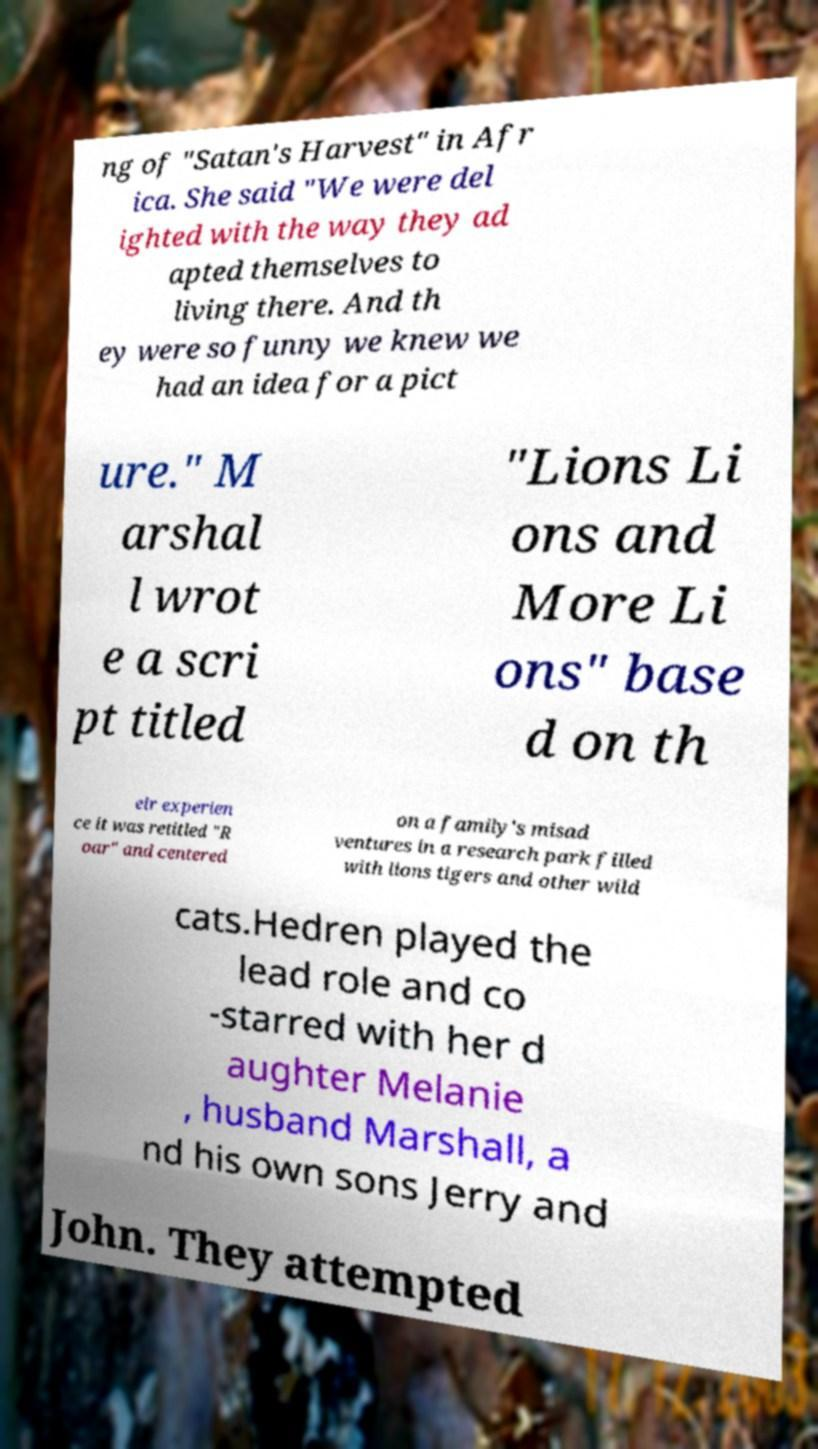For documentation purposes, I need the text within this image transcribed. Could you provide that? ng of "Satan's Harvest" in Afr ica. She said "We were del ighted with the way they ad apted themselves to living there. And th ey were so funny we knew we had an idea for a pict ure." M arshal l wrot e a scri pt titled "Lions Li ons and More Li ons" base d on th eir experien ce it was retitled "R oar" and centered on a family's misad ventures in a research park filled with lions tigers and other wild cats.Hedren played the lead role and co -starred with her d aughter Melanie , husband Marshall, a nd his own sons Jerry and John. They attempted 